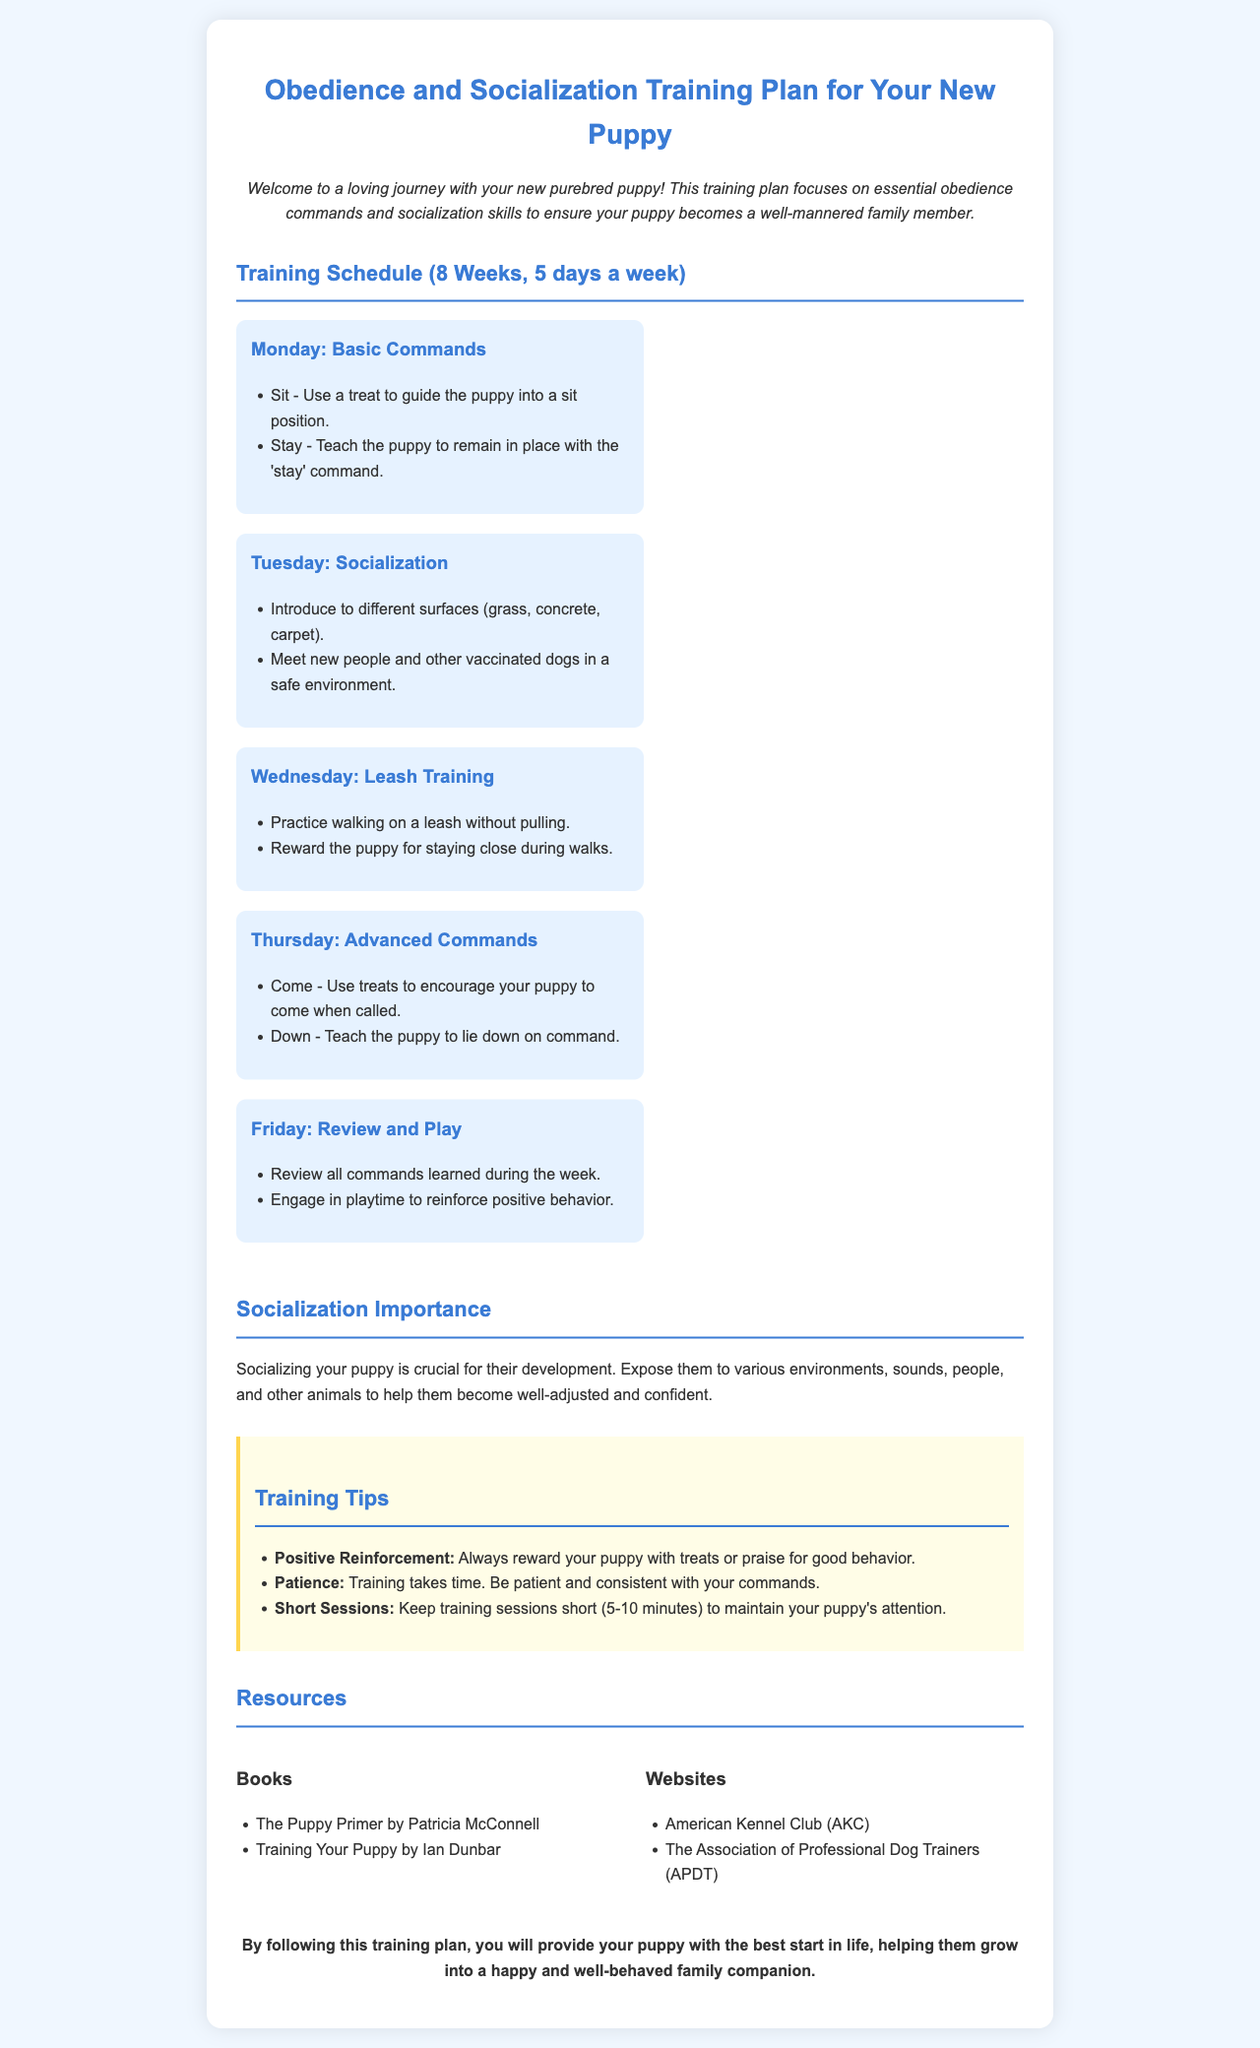What is the title of the document? The title of the document is indicated in the heading section of the document.
Answer: Obedience and Socialization Training Plan for Your New Puppy How many weeks is the training schedule? The document specifies that the training schedule lasts for 8 weeks.
Answer: 8 weeks What is taught on Tuesday? Tuesday's content includes specific activities related to socialization for the puppy.
Answer: Socialization What are the two commands taught on Monday? The commands list from Monday highlights basic commands for training the puppy.
Answer: Sit and Stay What should be the duration of each training session? The document provides guidance on training session length to ensure attention is maintained.
Answer: 5-10 minutes What is emphasized as important for socializing a puppy? The document discusses the significance of various experiences for the development of the puppy.
Answer: Development Which two books are recommended in the resources section? The resources section provides specific titles that are helpful for puppy training.
Answer: The Puppy Primer and Training Your Puppy What is a key tip on dog training? The tips section includes advice that enhances the effectiveness of puppy training.
Answer: Positive Reinforcement What will this training plan help your puppy become? This document concludes by summarizing the intended outcome of following the training plan.
Answer: A happy and well-behaved family companion 